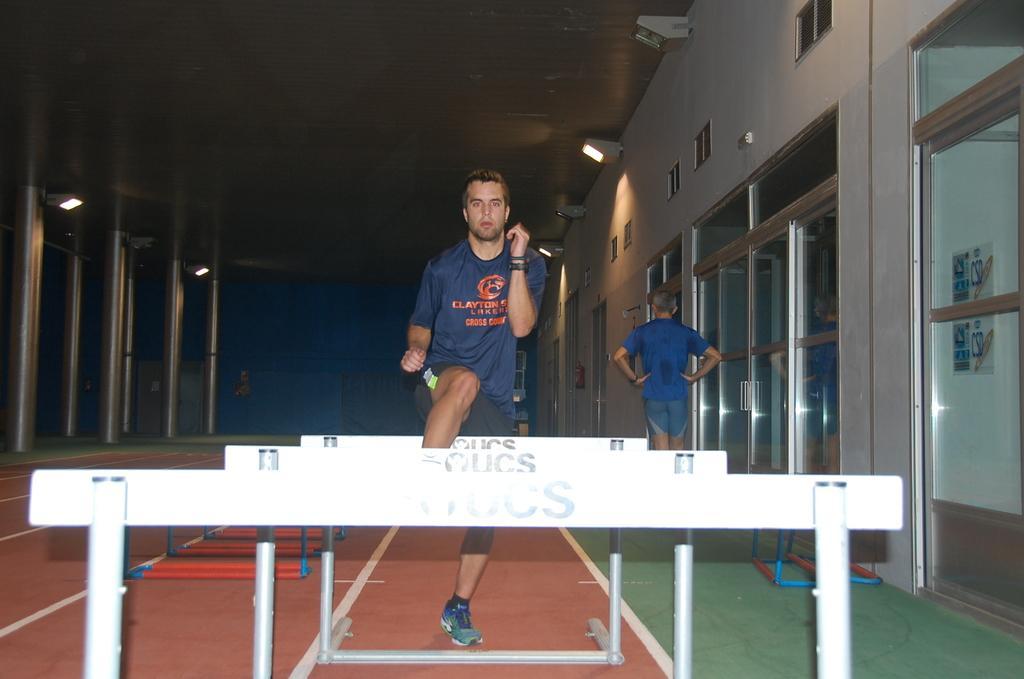How would you summarize this image in a sentence or two? In the image in the center, we can see one person standing. In front of him, we can see short poles and banners. In the background there is a wall, roof, glass, poster, lights and one person standing. 